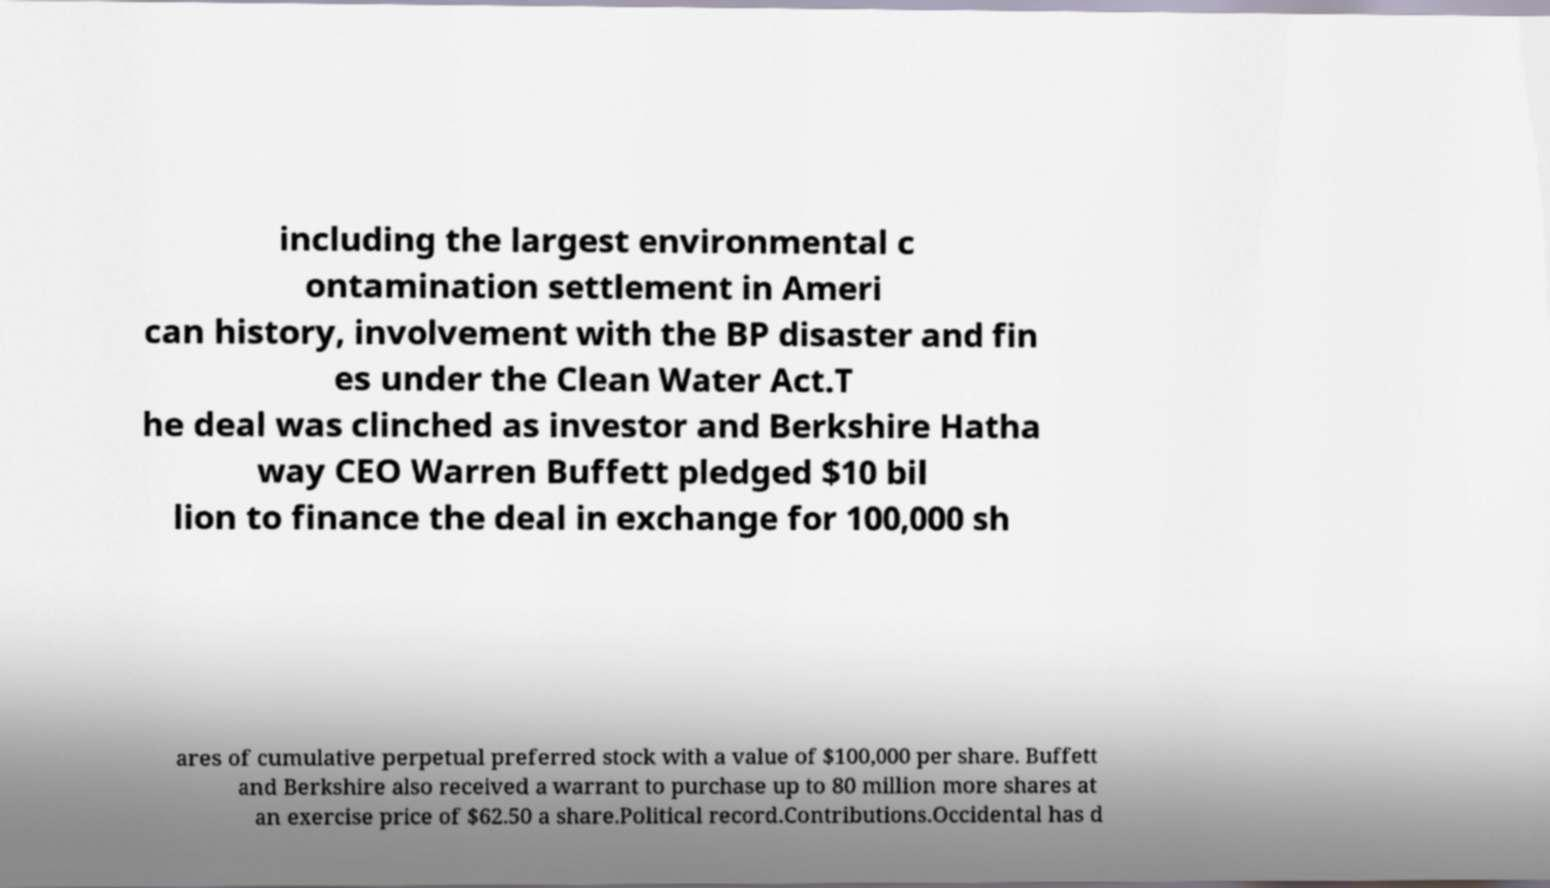Can you accurately transcribe the text from the provided image for me? including the largest environmental c ontamination settlement in Ameri can history, involvement with the BP disaster and fin es under the Clean Water Act.T he deal was clinched as investor and Berkshire Hatha way CEO Warren Buffett pledged $10 bil lion to finance the deal in exchange for 100,000 sh ares of cumulative perpetual preferred stock with a value of $100,000 per share. Buffett and Berkshire also received a warrant to purchase up to 80 million more shares at an exercise price of $62.50 a share.Political record.Contributions.Occidental has d 